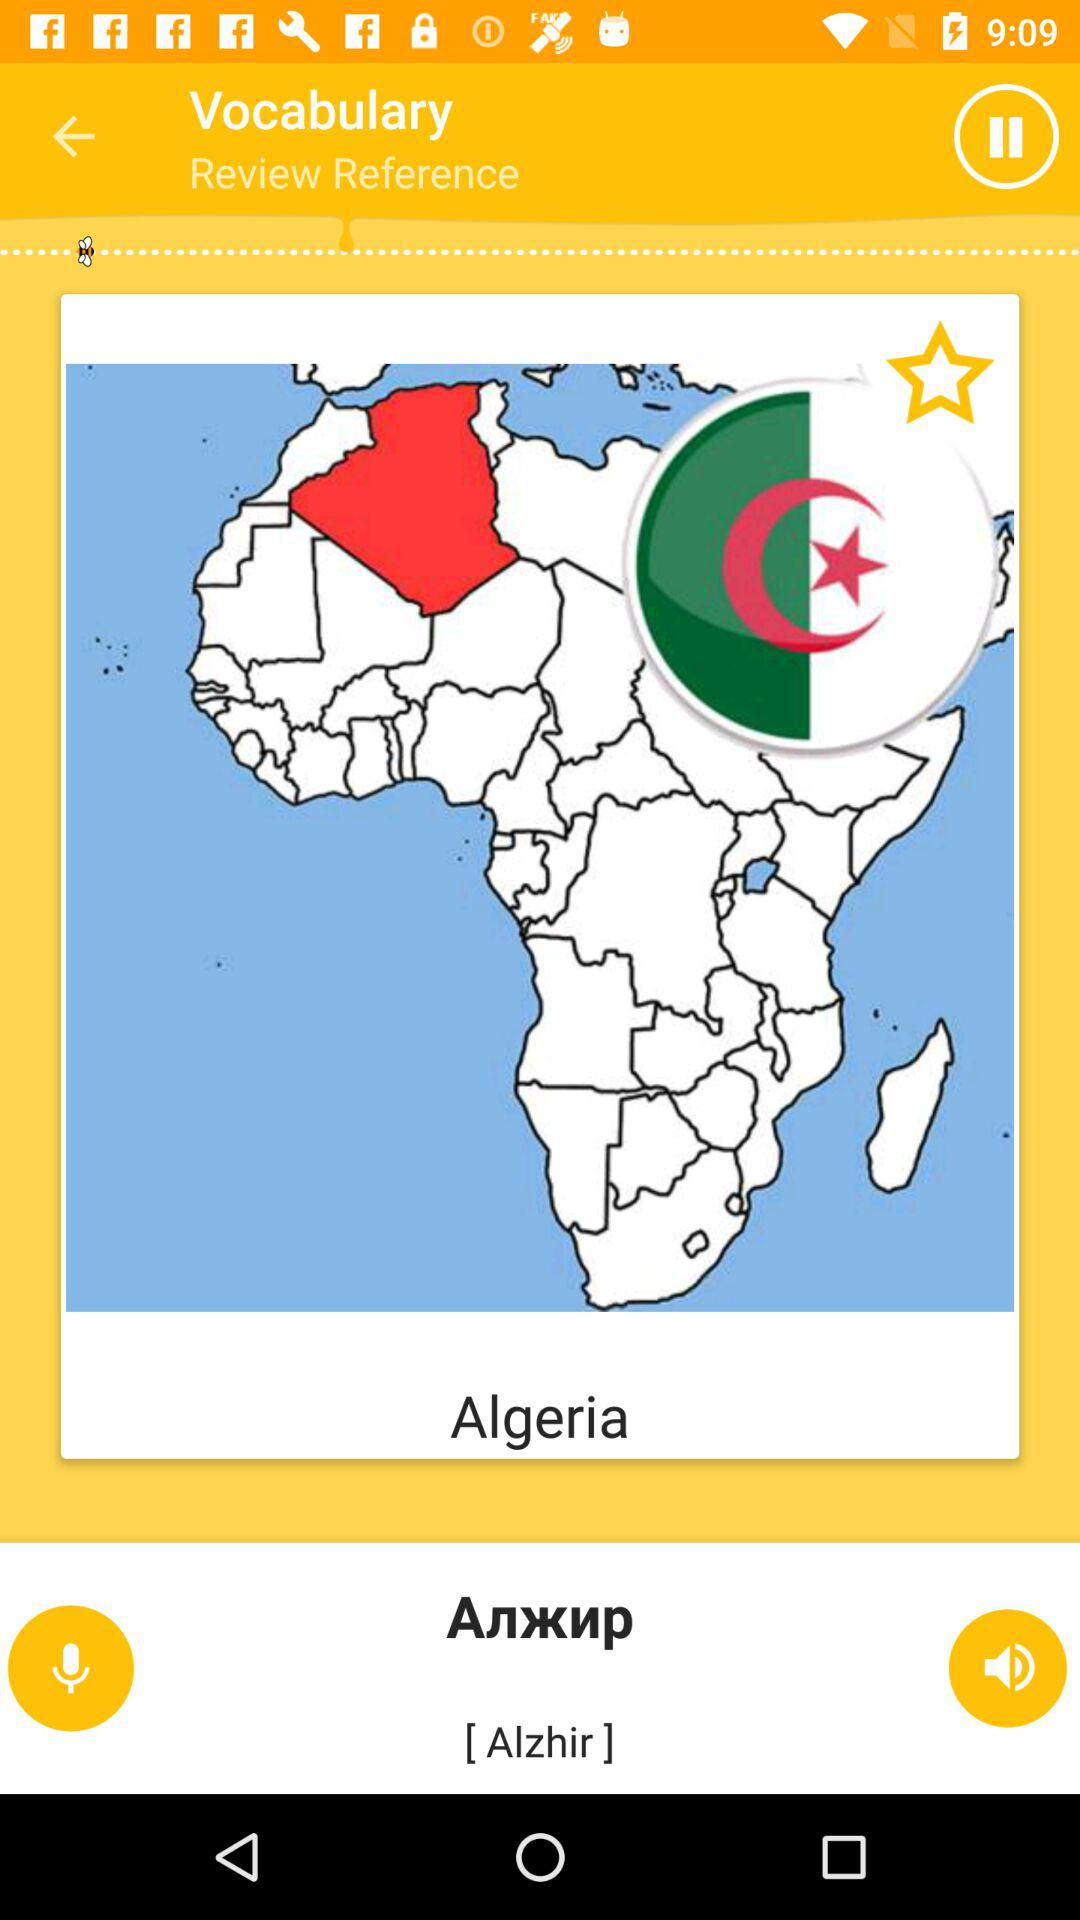What is the shown country name? The shown country name is Algeria. 